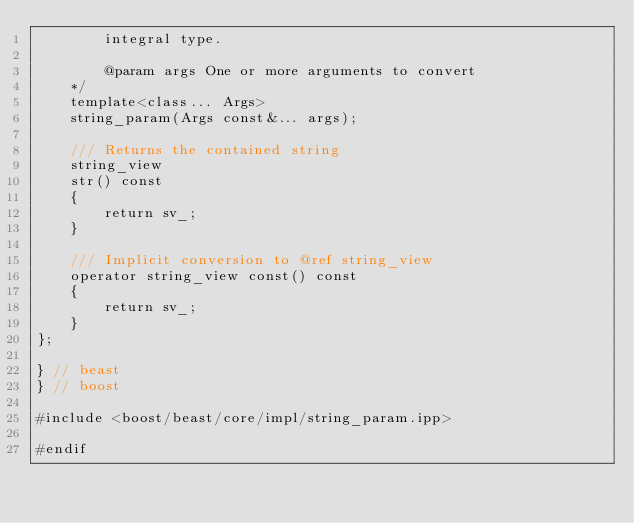<code> <loc_0><loc_0><loc_500><loc_500><_C++_>        integral type.

        @param args One or more arguments to convert
    */
    template<class... Args>
    string_param(Args const&... args);

    /// Returns the contained string
    string_view
    str() const
    {
        return sv_;
    }

    /// Implicit conversion to @ref string_view
    operator string_view const() const
    {
        return sv_;
    }
};

} // beast
} // boost

#include <boost/beast/core/impl/string_param.ipp>

#endif
</code> 